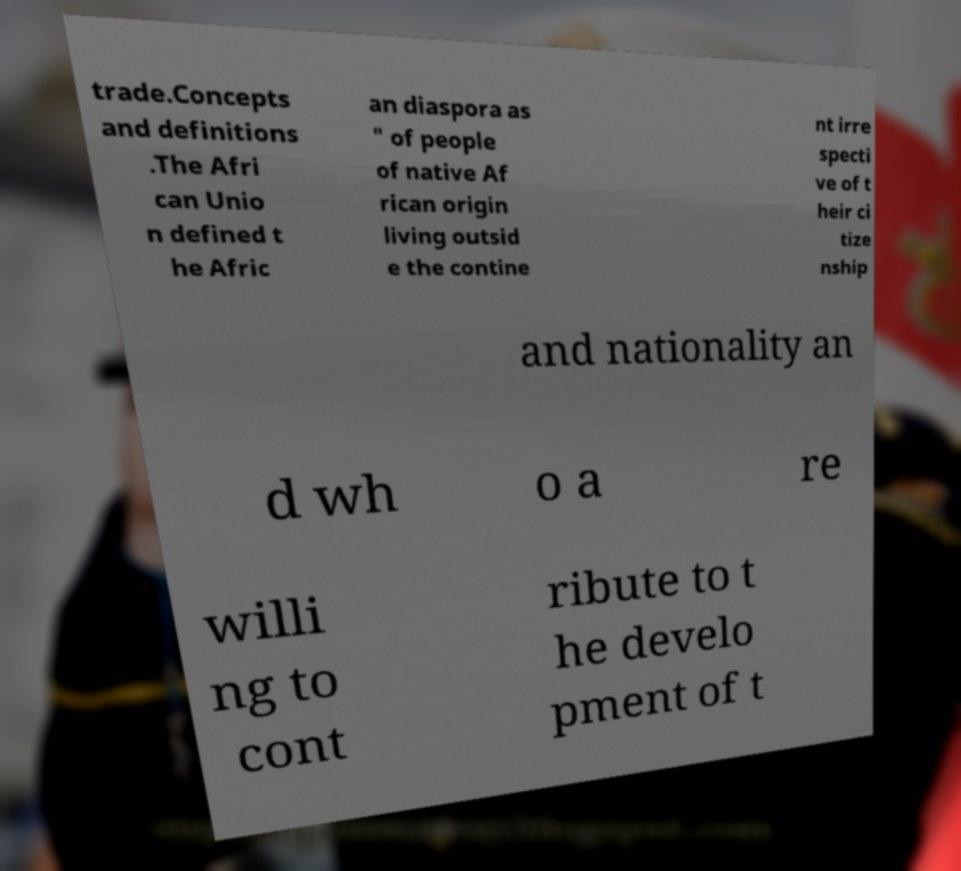For documentation purposes, I need the text within this image transcribed. Could you provide that? trade.Concepts and definitions .The Afri can Unio n defined t he Afric an diaspora as " of people of native Af rican origin living outsid e the contine nt irre specti ve of t heir ci tize nship and nationality an d wh o a re willi ng to cont ribute to t he develo pment of t 